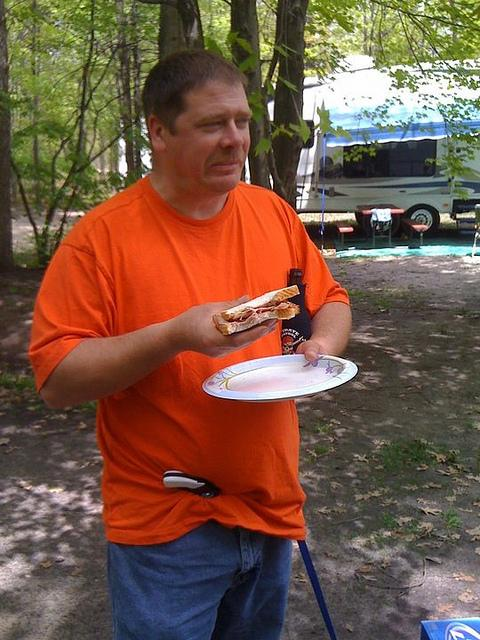How would this man defend himself if attacked?

Choices:
A) gun
B) knife
C) karate
D) he wouldn't gun 